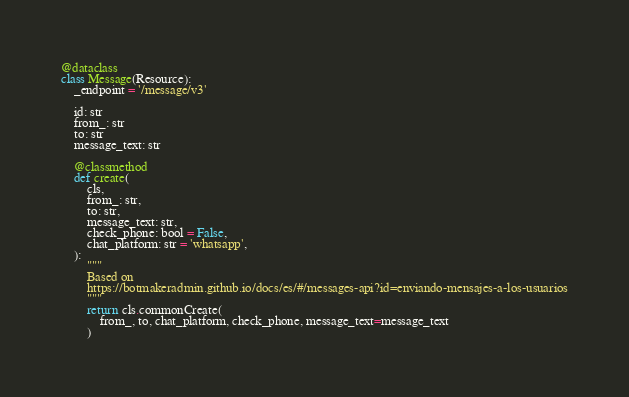Convert code to text. <code><loc_0><loc_0><loc_500><loc_500><_Python_>
@dataclass
class Message(Resource):
    _endpoint = '/message/v3'

    id: str
    from_: str
    to: str
    message_text: str

    @classmethod
    def create(
        cls,
        from_: str,
        to: str,
        message_text: str,
        check_phone: bool = False,
        chat_platform: str = 'whatsapp',
    ):
        """
        Based on
        https://botmakeradmin.github.io/docs/es/#/messages-api?id=enviando-mensajes-a-los-usuarios
        """
        return cls.commonCreate(
            from_, to, chat_platform, check_phone, message_text=message_text
        )
</code> 